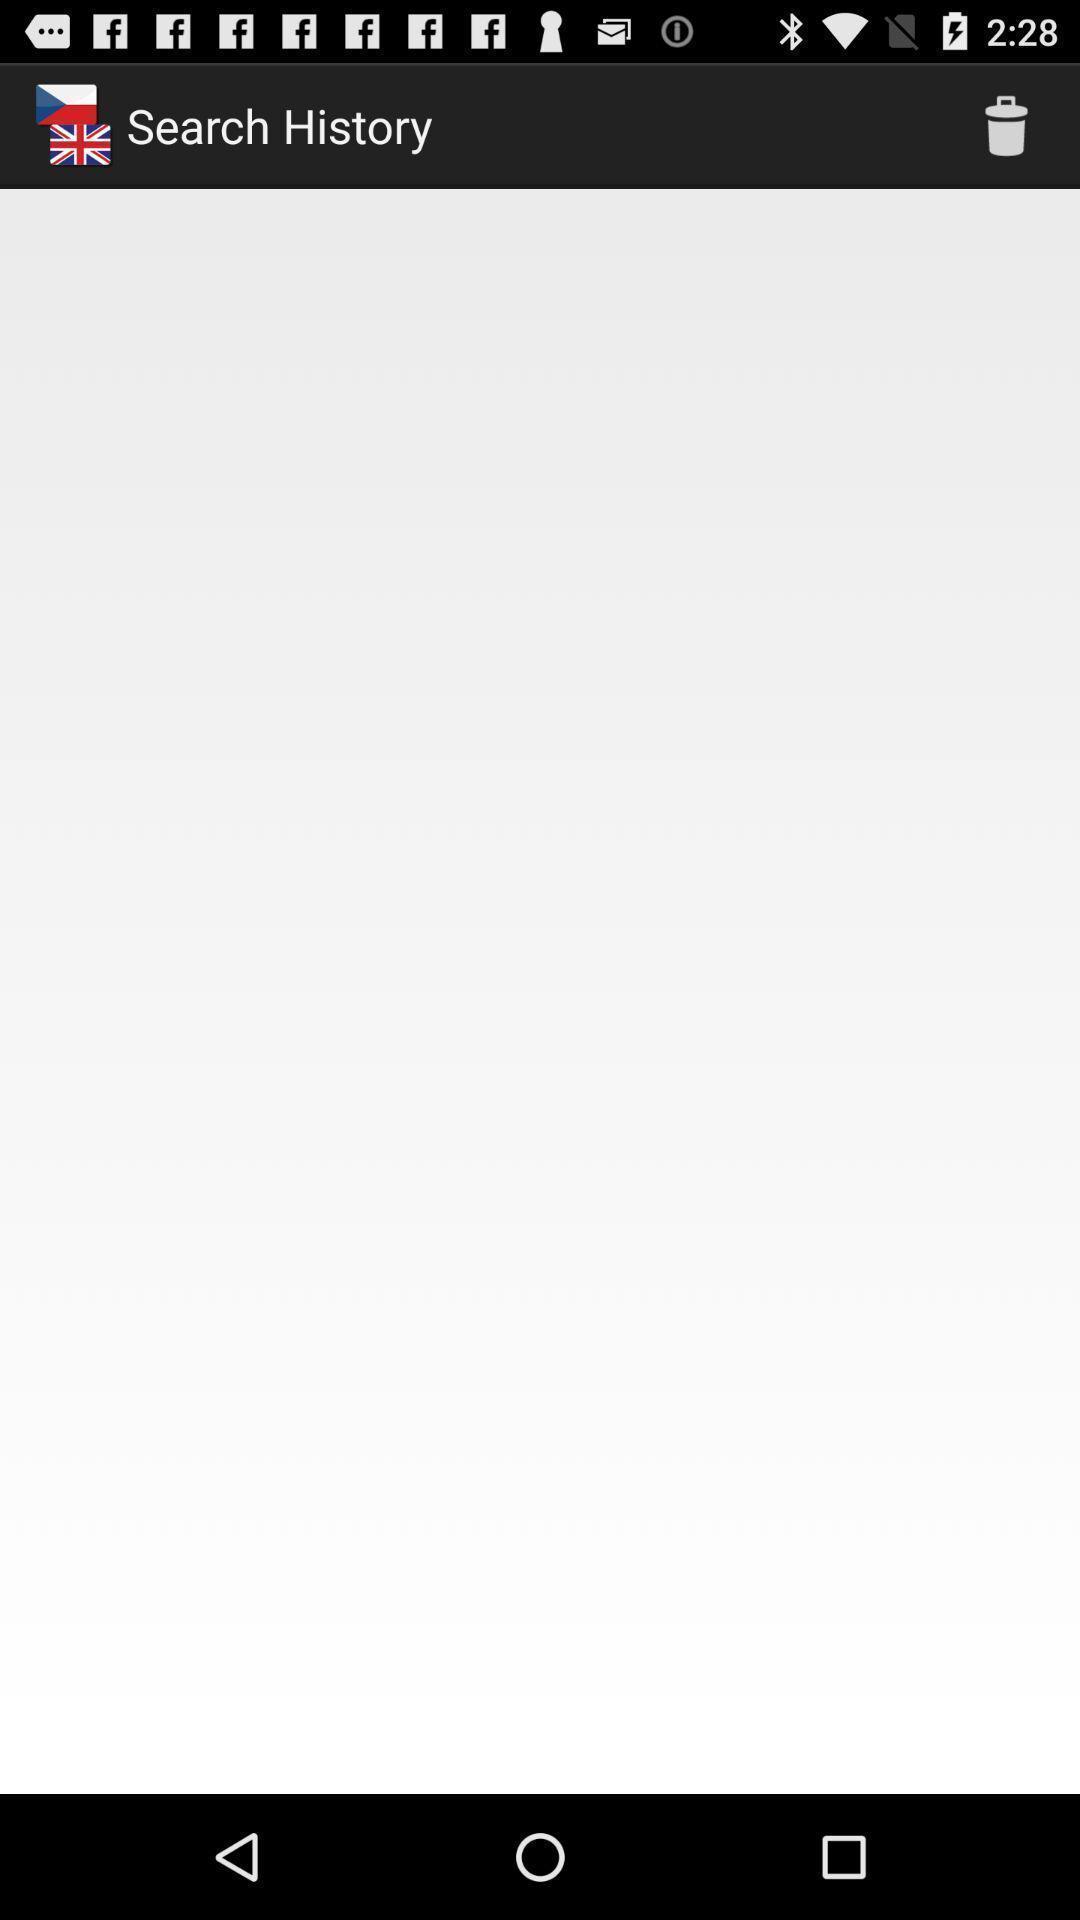Please provide a description for this image. Screen shows about search history. 